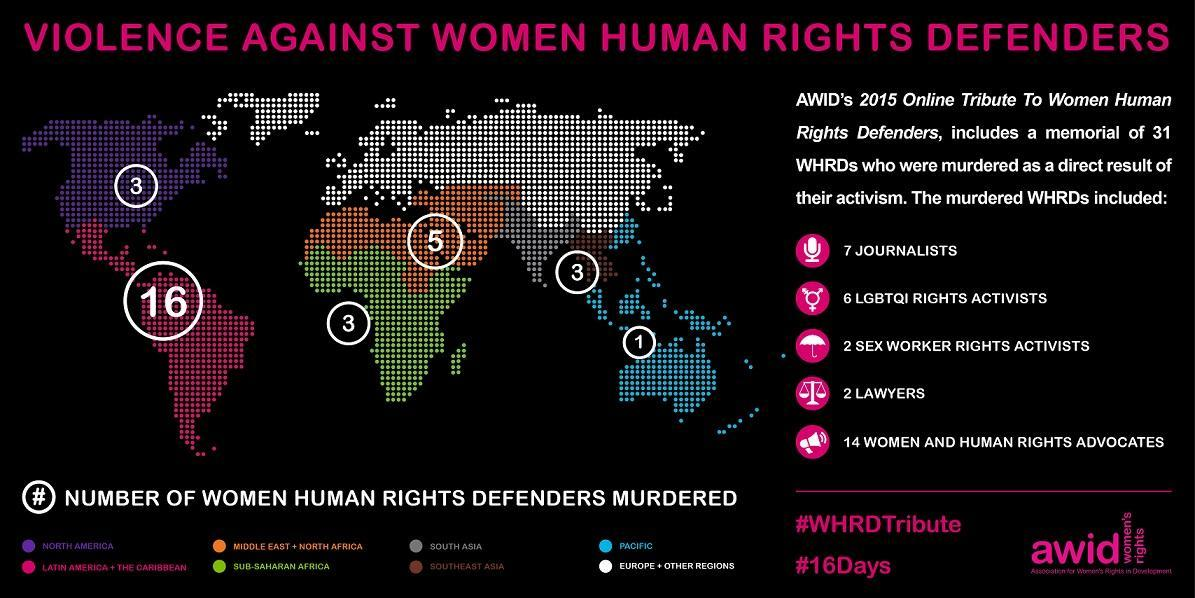What is the number of women human rights defenders murdered in North America?
Answer the question with a short phrase. 3 What is the number of women human rights defenders murdered in the Middle East + North Africa? 5 What is the total number of journalists and lawyers murdered? 9 What is the number of women human rights defenders murdered in Southeast Asia? 5 What is the number of women human rights defenders murdered in the Pacific? 1 